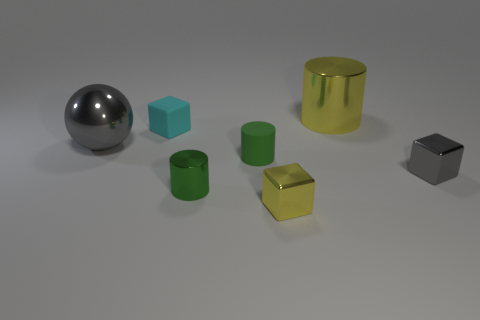Are there any other things that are the same shape as the large gray thing?
Ensure brevity in your answer.  No. What is the shape of the gray object that is the same size as the yellow metallic cylinder?
Your response must be concise. Sphere. How many things are either things in front of the cyan rubber thing or small rubber things?
Your answer should be very brief. 6. How many other objects are there of the same material as the cyan cube?
Give a very brief answer. 1. The small object that is the same color as the big ball is what shape?
Provide a short and direct response. Cube. There is a yellow metallic object that is behind the rubber block; what is its size?
Your answer should be compact. Large. The tiny gray thing that is made of the same material as the big yellow thing is what shape?
Ensure brevity in your answer.  Cube. Are the large yellow object and the large thing that is on the left side of the big yellow cylinder made of the same material?
Provide a short and direct response. Yes. There is a big yellow thing that is right of the green shiny object; does it have the same shape as the tiny cyan object?
Make the answer very short. No. What is the material of the yellow object that is the same shape as the cyan matte thing?
Keep it short and to the point. Metal. 